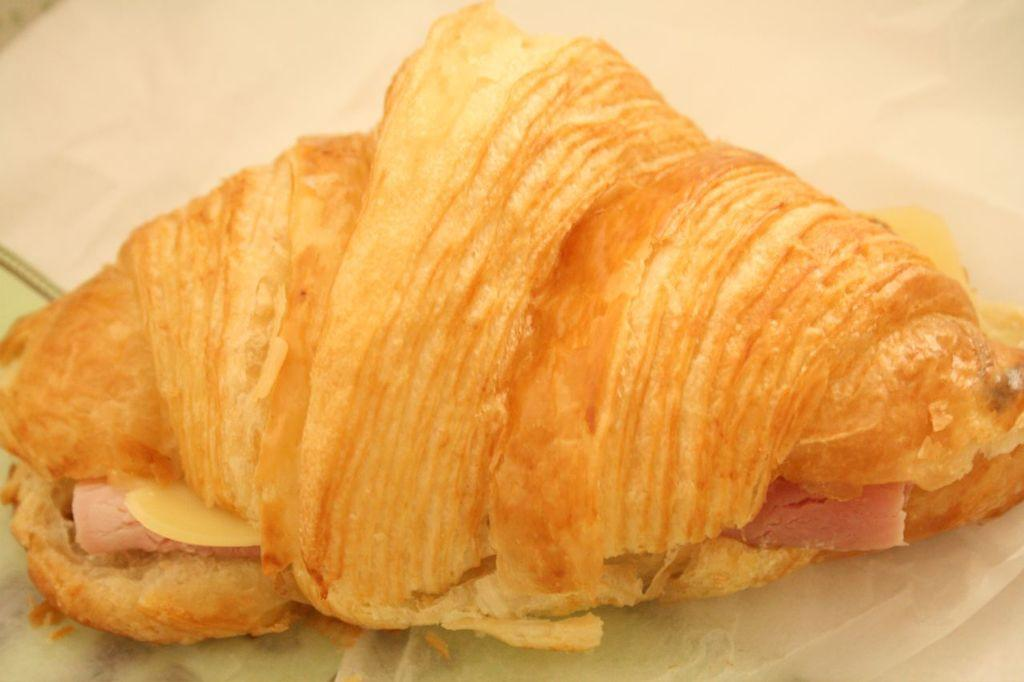What is the main subject in the center of the image? There is a food item in the center of the image. How is the food item positioned in the image? The food item is on a tissue. What route does the maid take to draw the attention of the guests in the image? There is no maid or guests present in the image, so it is not possible to determine a route or attention-drawing actions. 